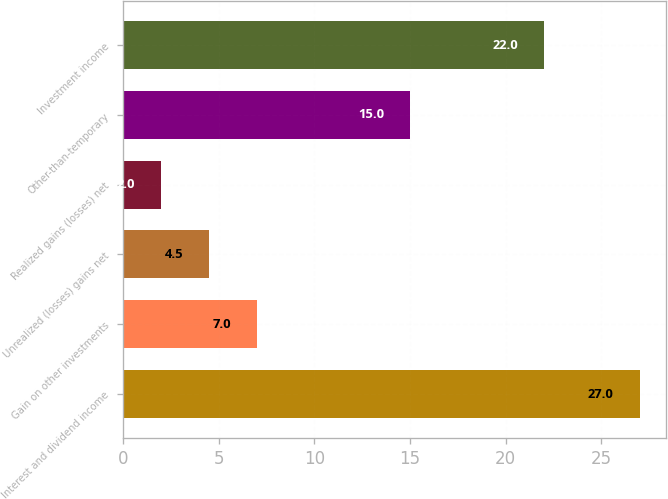Convert chart to OTSL. <chart><loc_0><loc_0><loc_500><loc_500><bar_chart><fcel>Interest and dividend income<fcel>Gain on other investments<fcel>Unrealized (losses) gains net<fcel>Realized gains (losses) net<fcel>Other-than-temporary<fcel>Investment income<nl><fcel>27<fcel>7<fcel>4.5<fcel>2<fcel>15<fcel>22<nl></chart> 